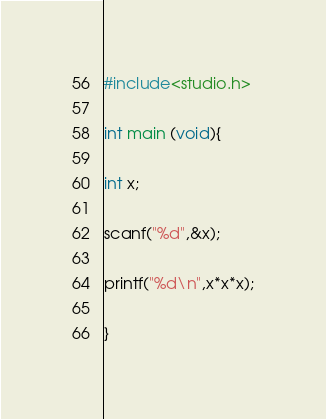<code> <loc_0><loc_0><loc_500><loc_500><_C_>#include<studio.h>

int main (void){

int x;

scanf("%d",&x);

printf("%d\n",x*x*x);

}</code> 